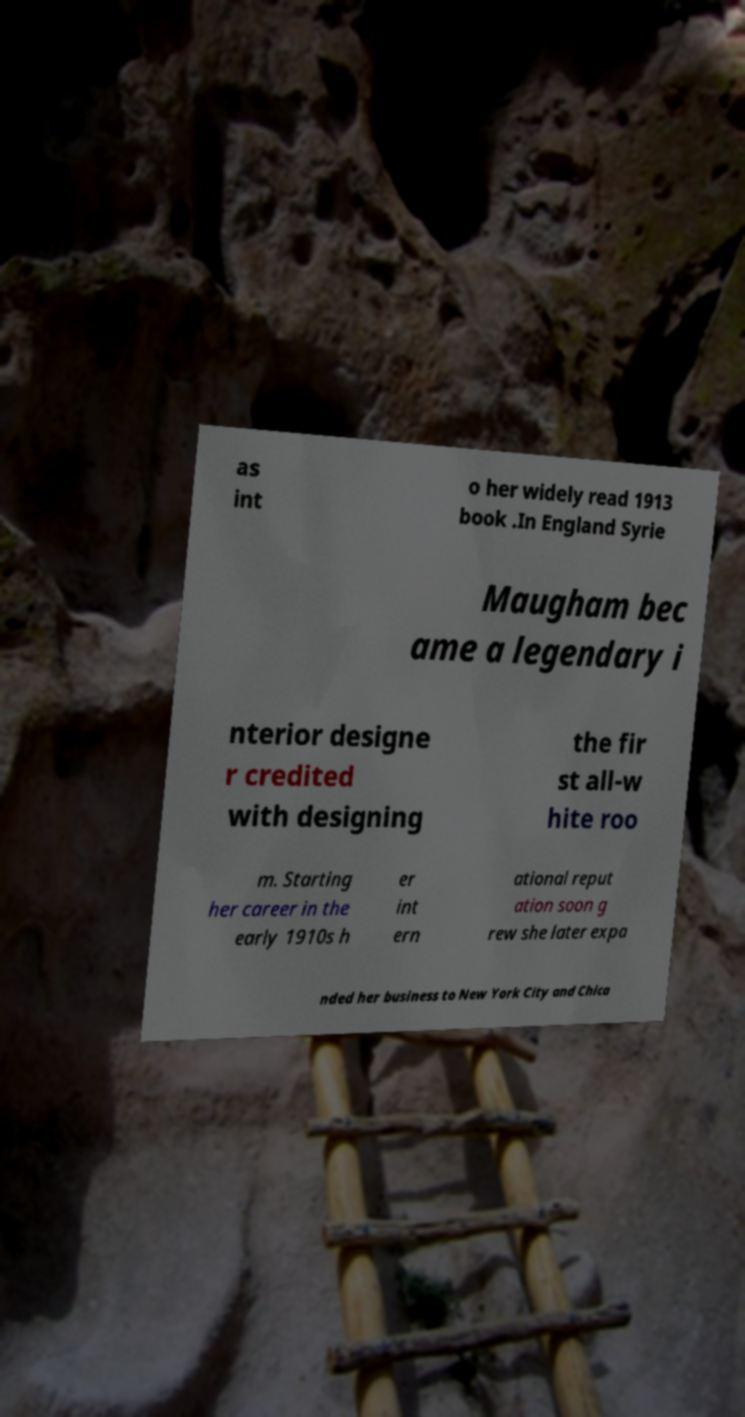I need the written content from this picture converted into text. Can you do that? as int o her widely read 1913 book .In England Syrie Maugham bec ame a legendary i nterior designe r credited with designing the fir st all-w hite roo m. Starting her career in the early 1910s h er int ern ational reput ation soon g rew she later expa nded her business to New York City and Chica 